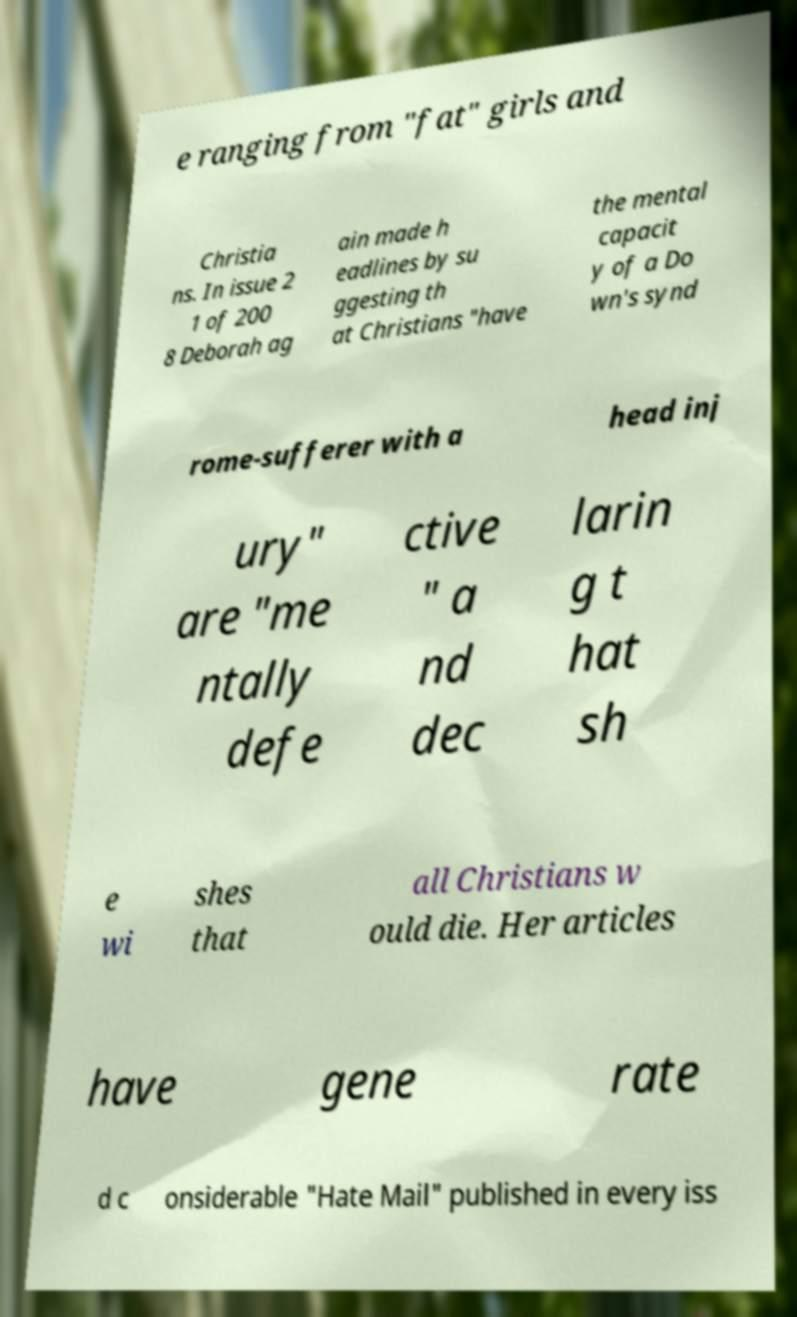Please read and relay the text visible in this image. What does it say? e ranging from "fat" girls and Christia ns. In issue 2 1 of 200 8 Deborah ag ain made h eadlines by su ggesting th at Christians "have the mental capacit y of a Do wn's synd rome-sufferer with a head inj ury" are "me ntally defe ctive " a nd dec larin g t hat sh e wi shes that all Christians w ould die. Her articles have gene rate d c onsiderable "Hate Mail" published in every iss 